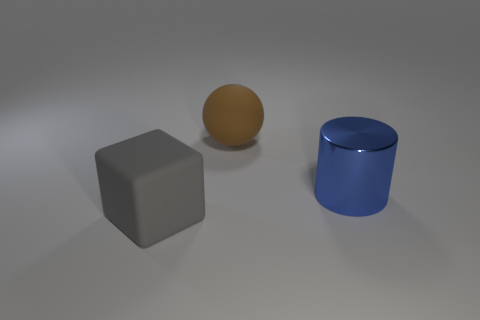Is there any other thing that is the same material as the blue object?
Your answer should be compact. No. How many gray matte objects are there?
Offer a very short reply. 1. Are there fewer gray rubber objects that are left of the large brown ball than big matte things that are to the left of the large metal cylinder?
Your answer should be very brief. Yes. Is the number of brown matte spheres in front of the brown sphere less than the number of large cylinders?
Make the answer very short. Yes. What is the material of the big thing in front of the thing on the right side of the big matte thing that is behind the cube?
Make the answer very short. Rubber. How many things are matte objects that are in front of the ball or matte things right of the gray matte cube?
Make the answer very short. 2. What number of metallic objects are either gray cubes or yellow objects?
Your answer should be very brief. 0. What shape is the large brown thing that is made of the same material as the big gray thing?
Ensure brevity in your answer.  Sphere. What number of things are either shiny objects or things right of the ball?
Make the answer very short. 1. What number of blocks have the same size as the brown matte ball?
Your response must be concise. 1. 